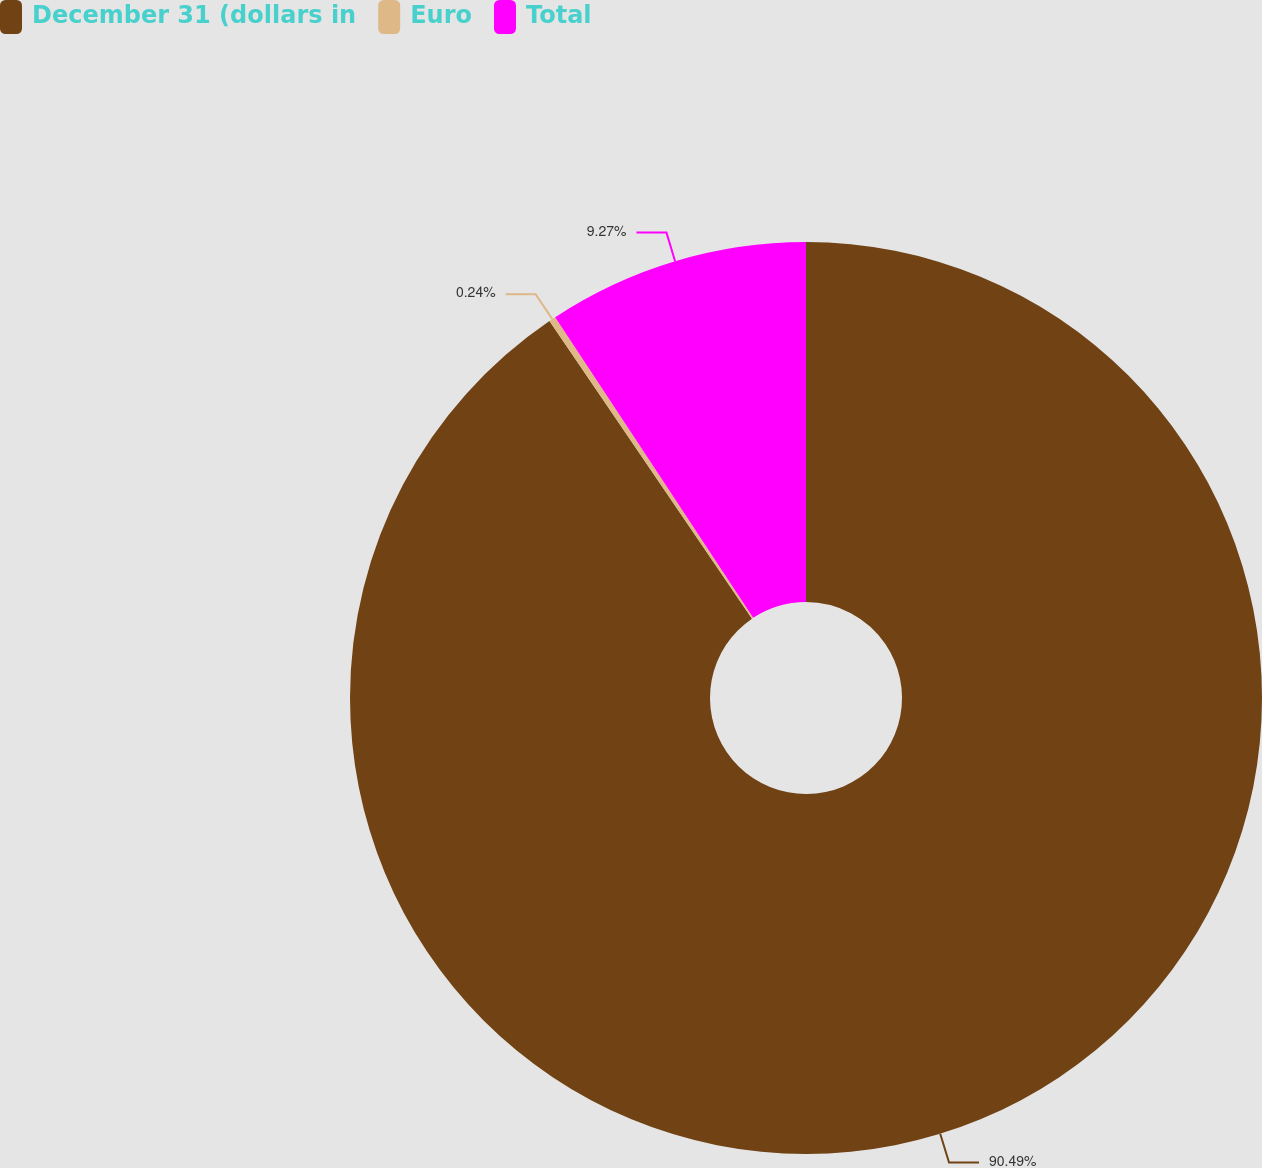Convert chart to OTSL. <chart><loc_0><loc_0><loc_500><loc_500><pie_chart><fcel>December 31 (dollars in<fcel>Euro<fcel>Total<nl><fcel>90.49%<fcel>0.24%<fcel>9.27%<nl></chart> 